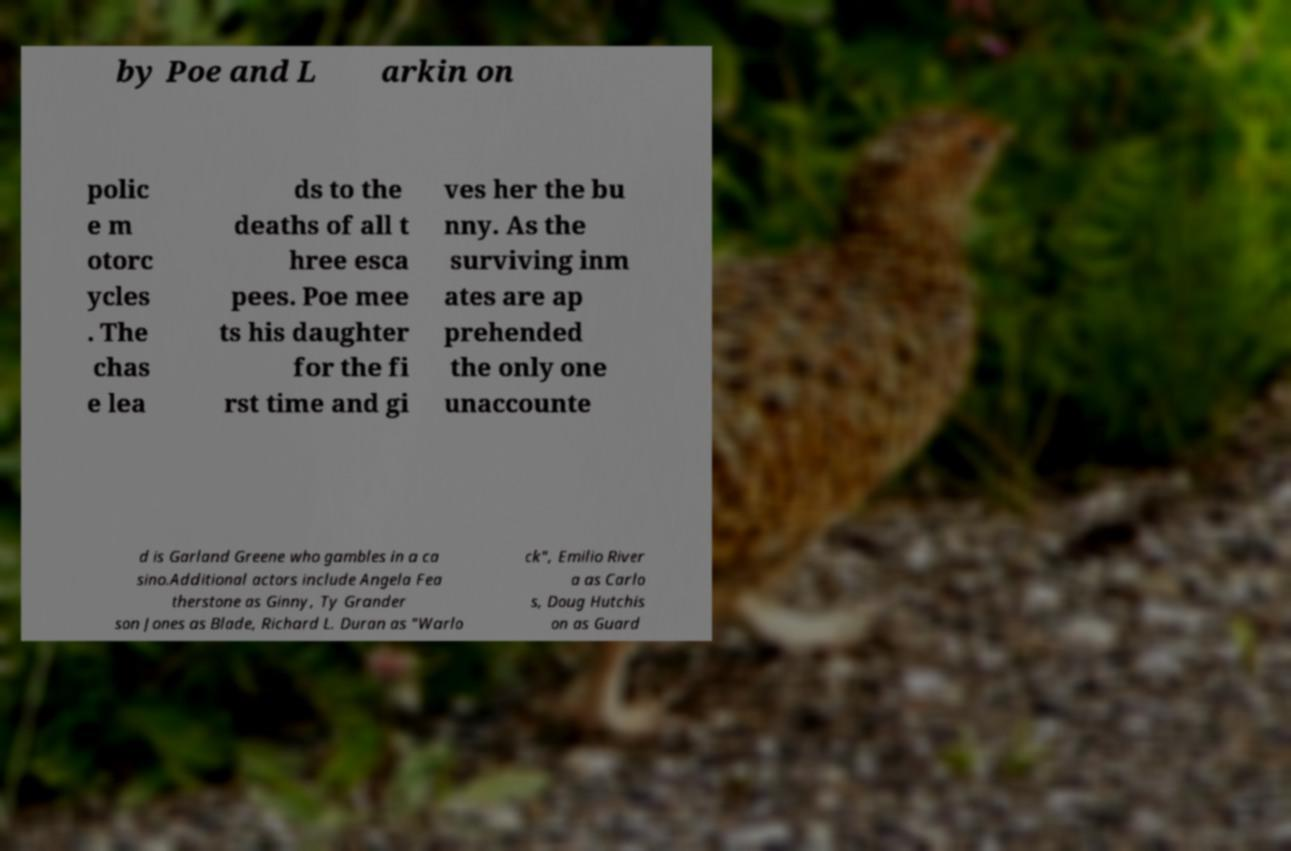Please identify and transcribe the text found in this image. by Poe and L arkin on polic e m otorc ycles . The chas e lea ds to the deaths of all t hree esca pees. Poe mee ts his daughter for the fi rst time and gi ves her the bu nny. As the surviving inm ates are ap prehended the only one unaccounte d is Garland Greene who gambles in a ca sino.Additional actors include Angela Fea therstone as Ginny, Ty Grander son Jones as Blade, Richard L. Duran as "Warlo ck", Emilio River a as Carlo s, Doug Hutchis on as Guard 